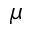<formula> <loc_0><loc_0><loc_500><loc_500>\mu</formula> 